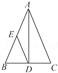Could you explain if triangle ADE is similar to triangle ABC, and if so, what the criteria for this similarity would be? Triangle ADE is indeed similar to triangle ABC, and this can be determined by Angle-Angle (AA) similarity criterion. Since AD is perpendicular to BC, angle ADE is a right angle and is thus congruent to angle ACB which is also a right angle because AD is the altitude. Additionally, angle DAE is shared by both triangles. Therefore, these two pairs of congruent angles establish that the triangles are similar by the AA criterion. 